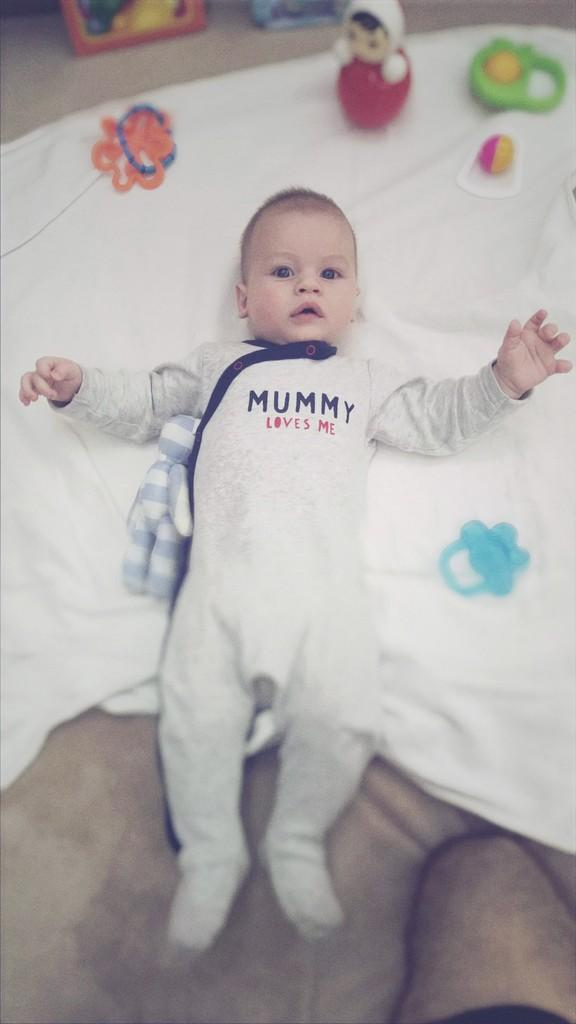What is the position of the child in the image? The child is lying in the image. What is located at the bottom of the image? There is cloth at the bottom of the image. Can you describe any body parts visible in the image? A person's leg is visible at the right bottom of the image. What else can be seen in the image besides the child and the cloth? There are toys in the image. What type of rain is falling in the image? There is no rain present in the image. Can you describe the eye color of the child in the image? The image does not provide enough detail to determine the child's eye color. 